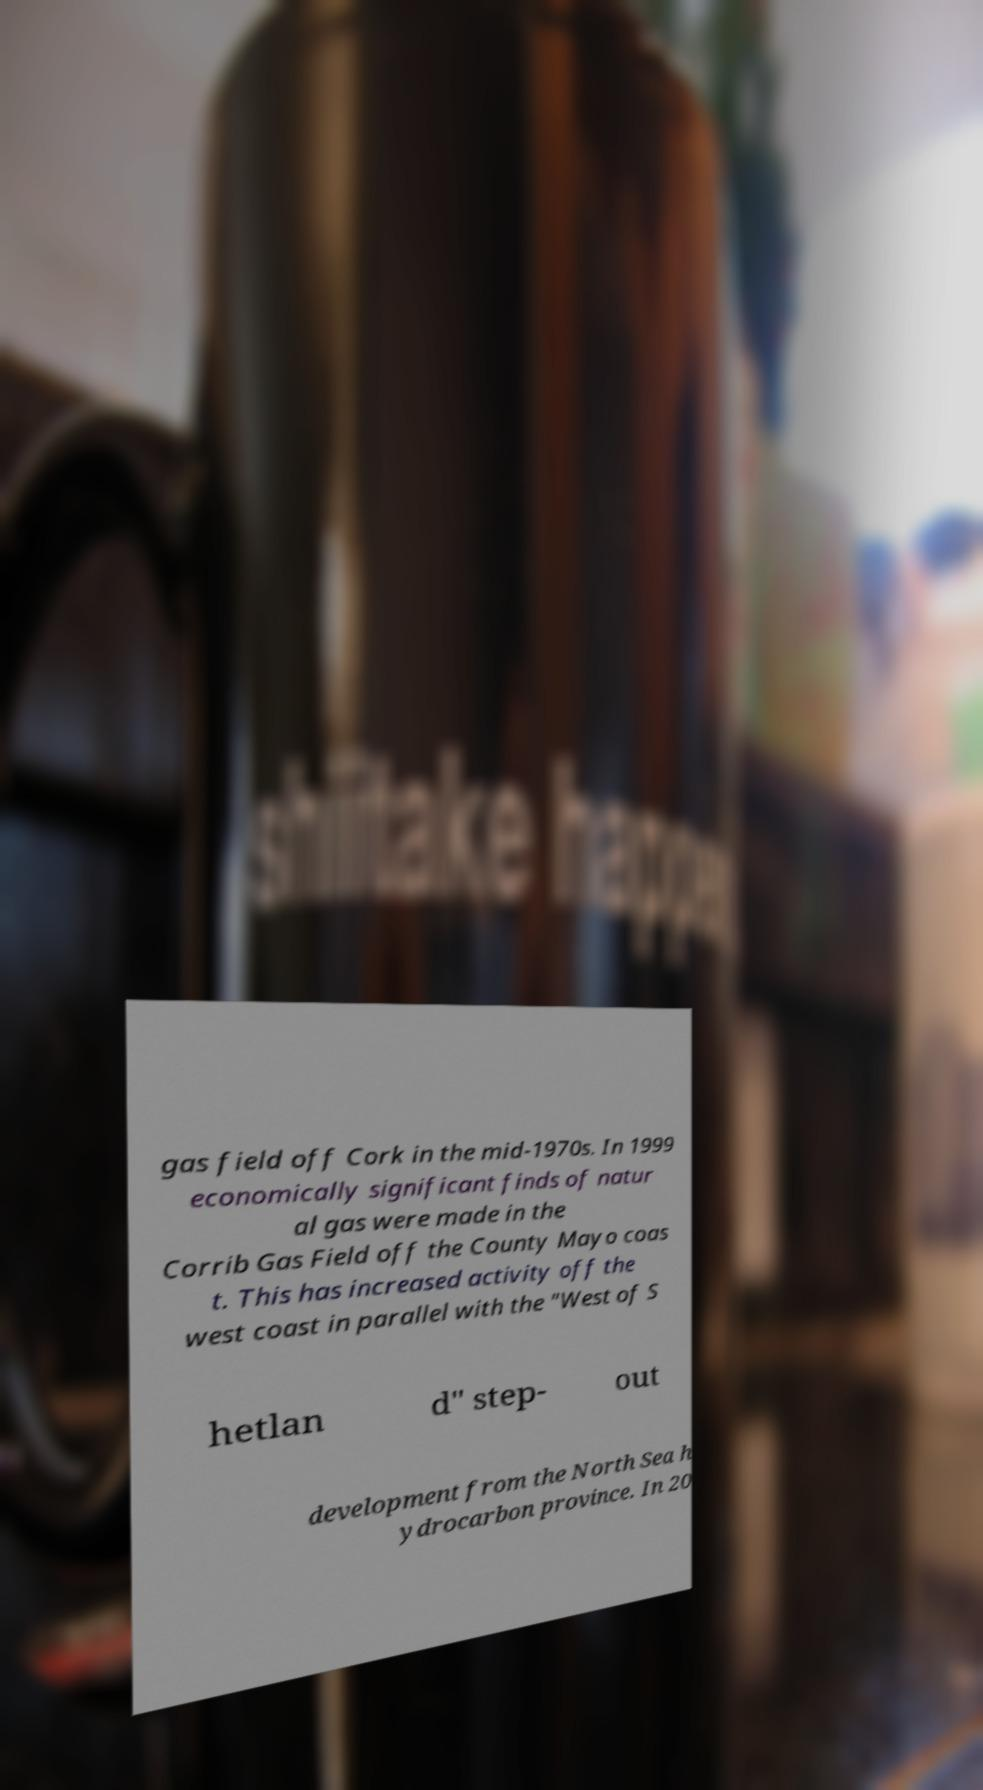Can you accurately transcribe the text from the provided image for me? gas field off Cork in the mid-1970s. In 1999 economically significant finds of natur al gas were made in the Corrib Gas Field off the County Mayo coas t. This has increased activity off the west coast in parallel with the "West of S hetlan d" step- out development from the North Sea h ydrocarbon province. In 20 